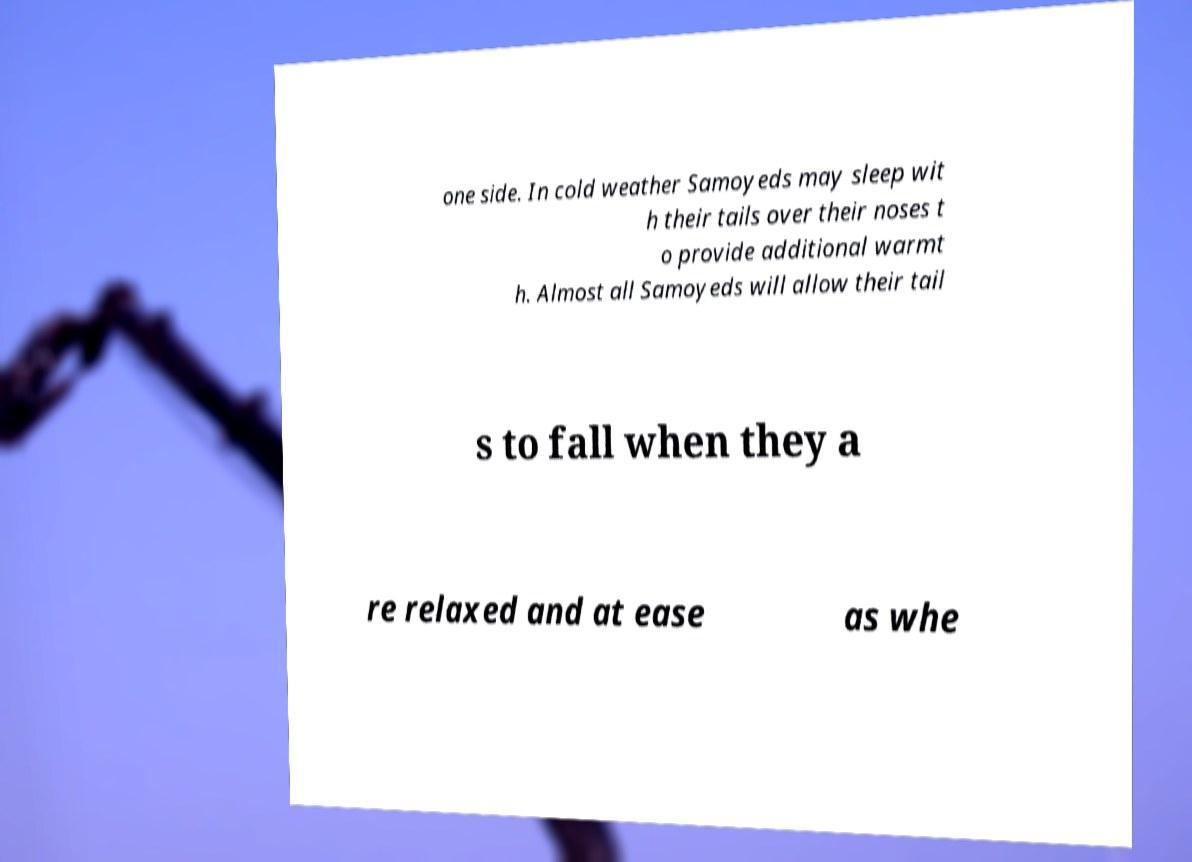There's text embedded in this image that I need extracted. Can you transcribe it verbatim? one side. In cold weather Samoyeds may sleep wit h their tails over their noses t o provide additional warmt h. Almost all Samoyeds will allow their tail s to fall when they a re relaxed and at ease as whe 